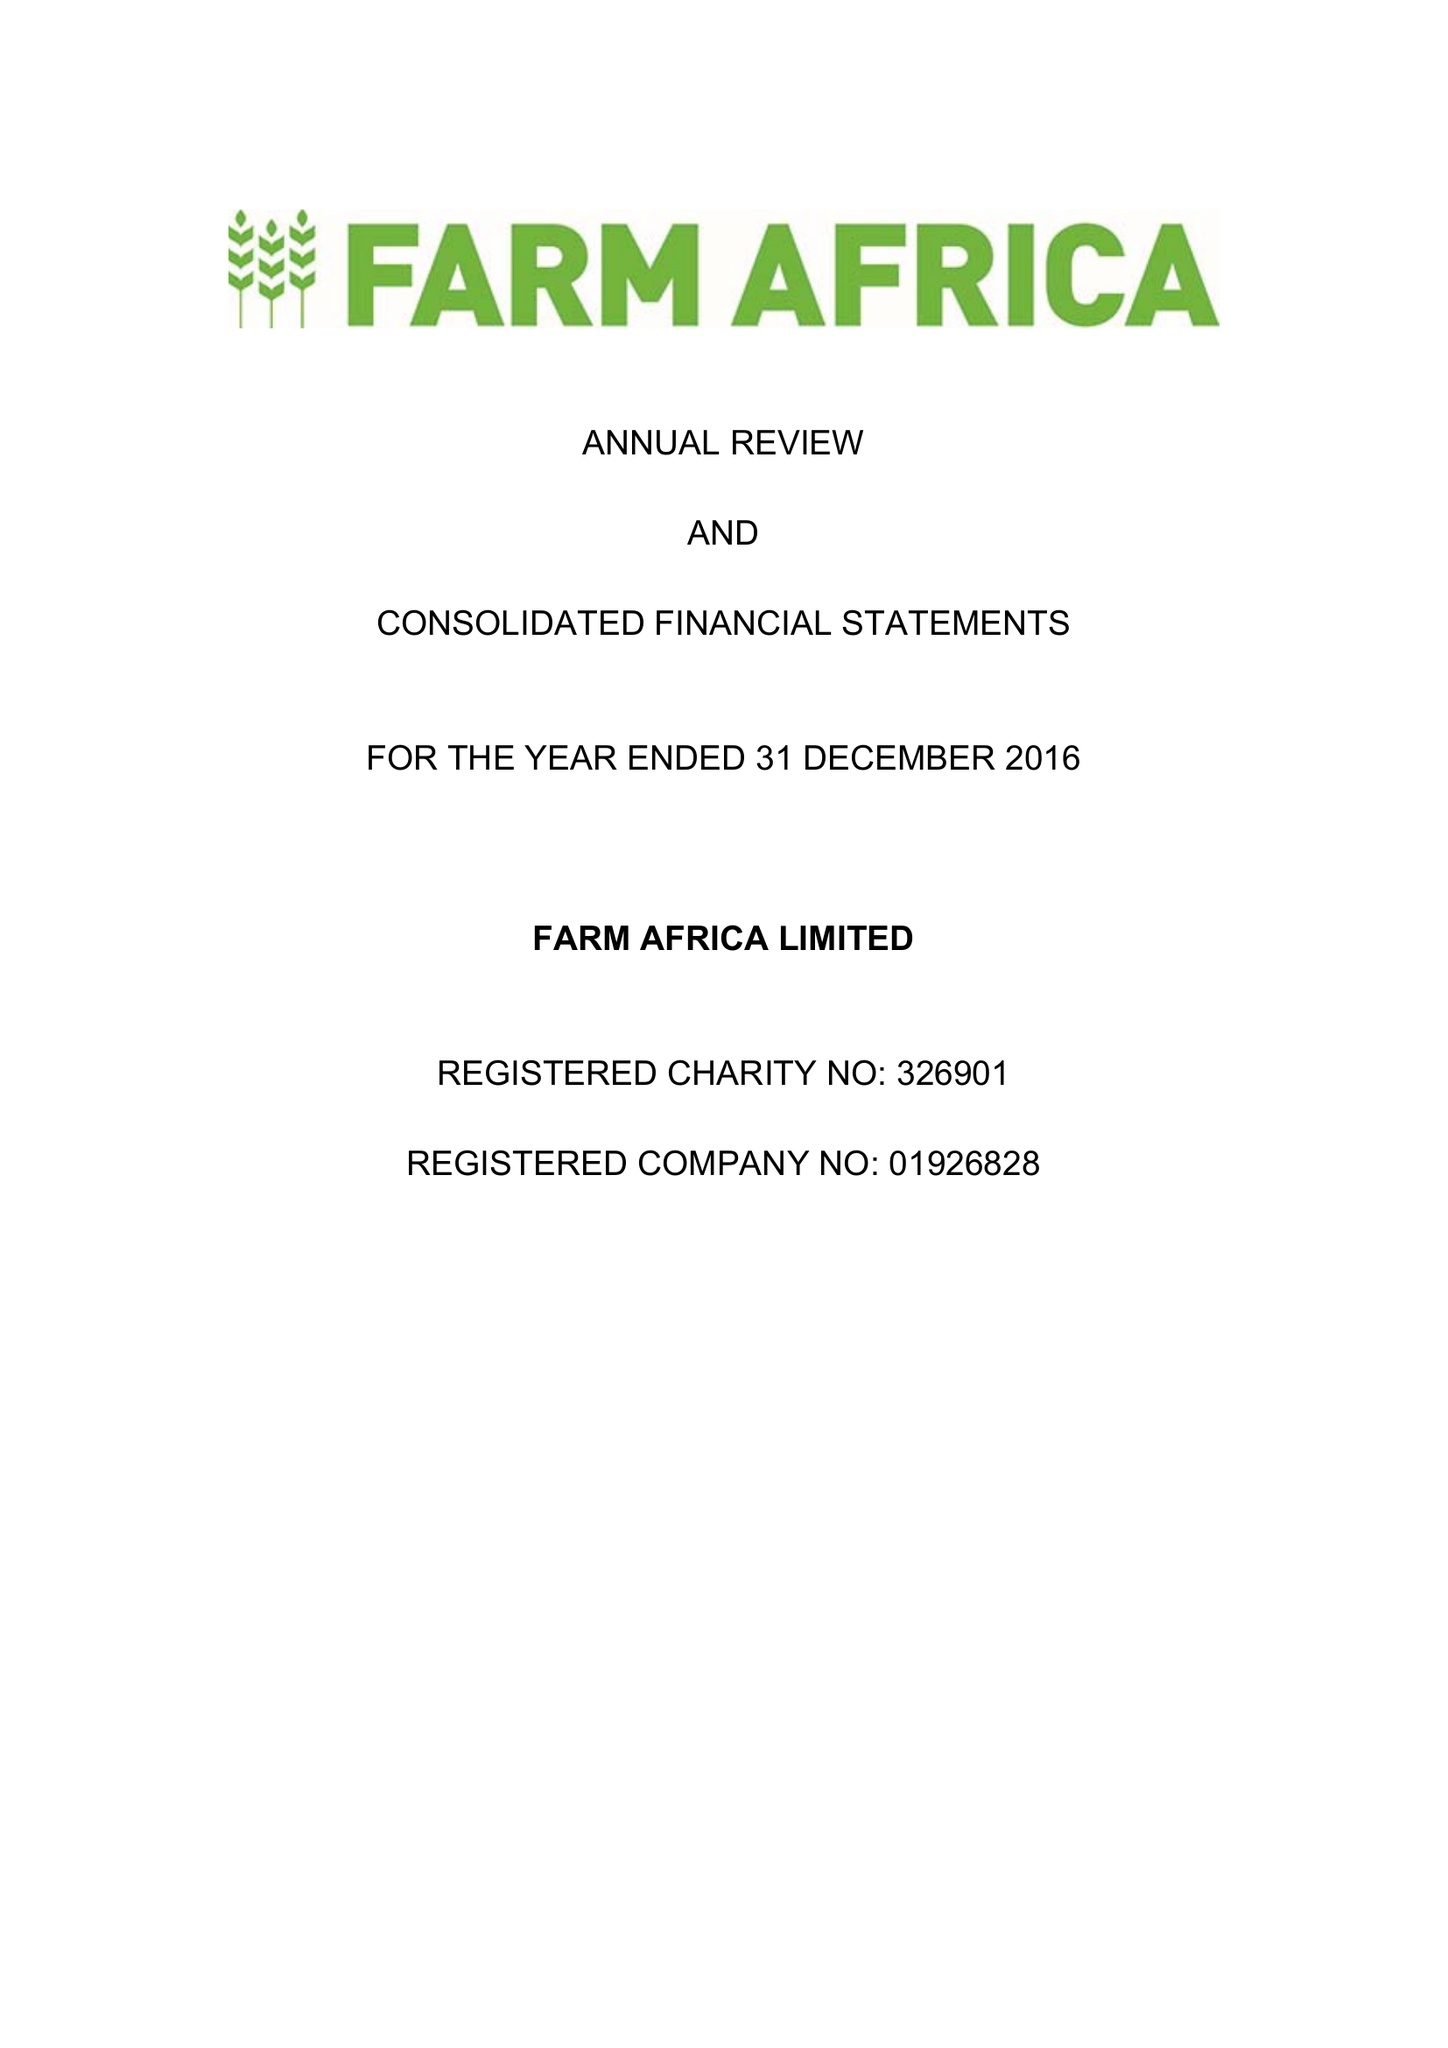What is the value for the address__post_town?
Answer the question using a single word or phrase. LONDON 